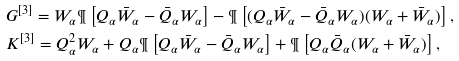<formula> <loc_0><loc_0><loc_500><loc_500>& G ^ { [ 3 ] } = W _ { \alpha } \P \left [ Q _ { \alpha } \bar { W } _ { \alpha } - \bar { Q } _ { \alpha } W _ { \alpha } \right ] - \P \left [ ( Q _ { \alpha } \bar { W } _ { \alpha } - \bar { Q } _ { \alpha } W _ { \alpha } ) ( W _ { \alpha } + \bar { W } _ { \alpha } ) \right ] , \\ & K ^ { [ 3 ] } = Q _ { \alpha } ^ { 2 } W _ { \alpha } + Q _ { \alpha } \P \left [ Q _ { \alpha } \bar { W } _ { \alpha } - \bar { Q } _ { \alpha } W _ { \alpha } \right ] + \P \left [ Q _ { \alpha } \bar { Q } _ { \alpha } ( W _ { \alpha } + \bar { W } _ { \alpha } ) \right ] ,</formula> 